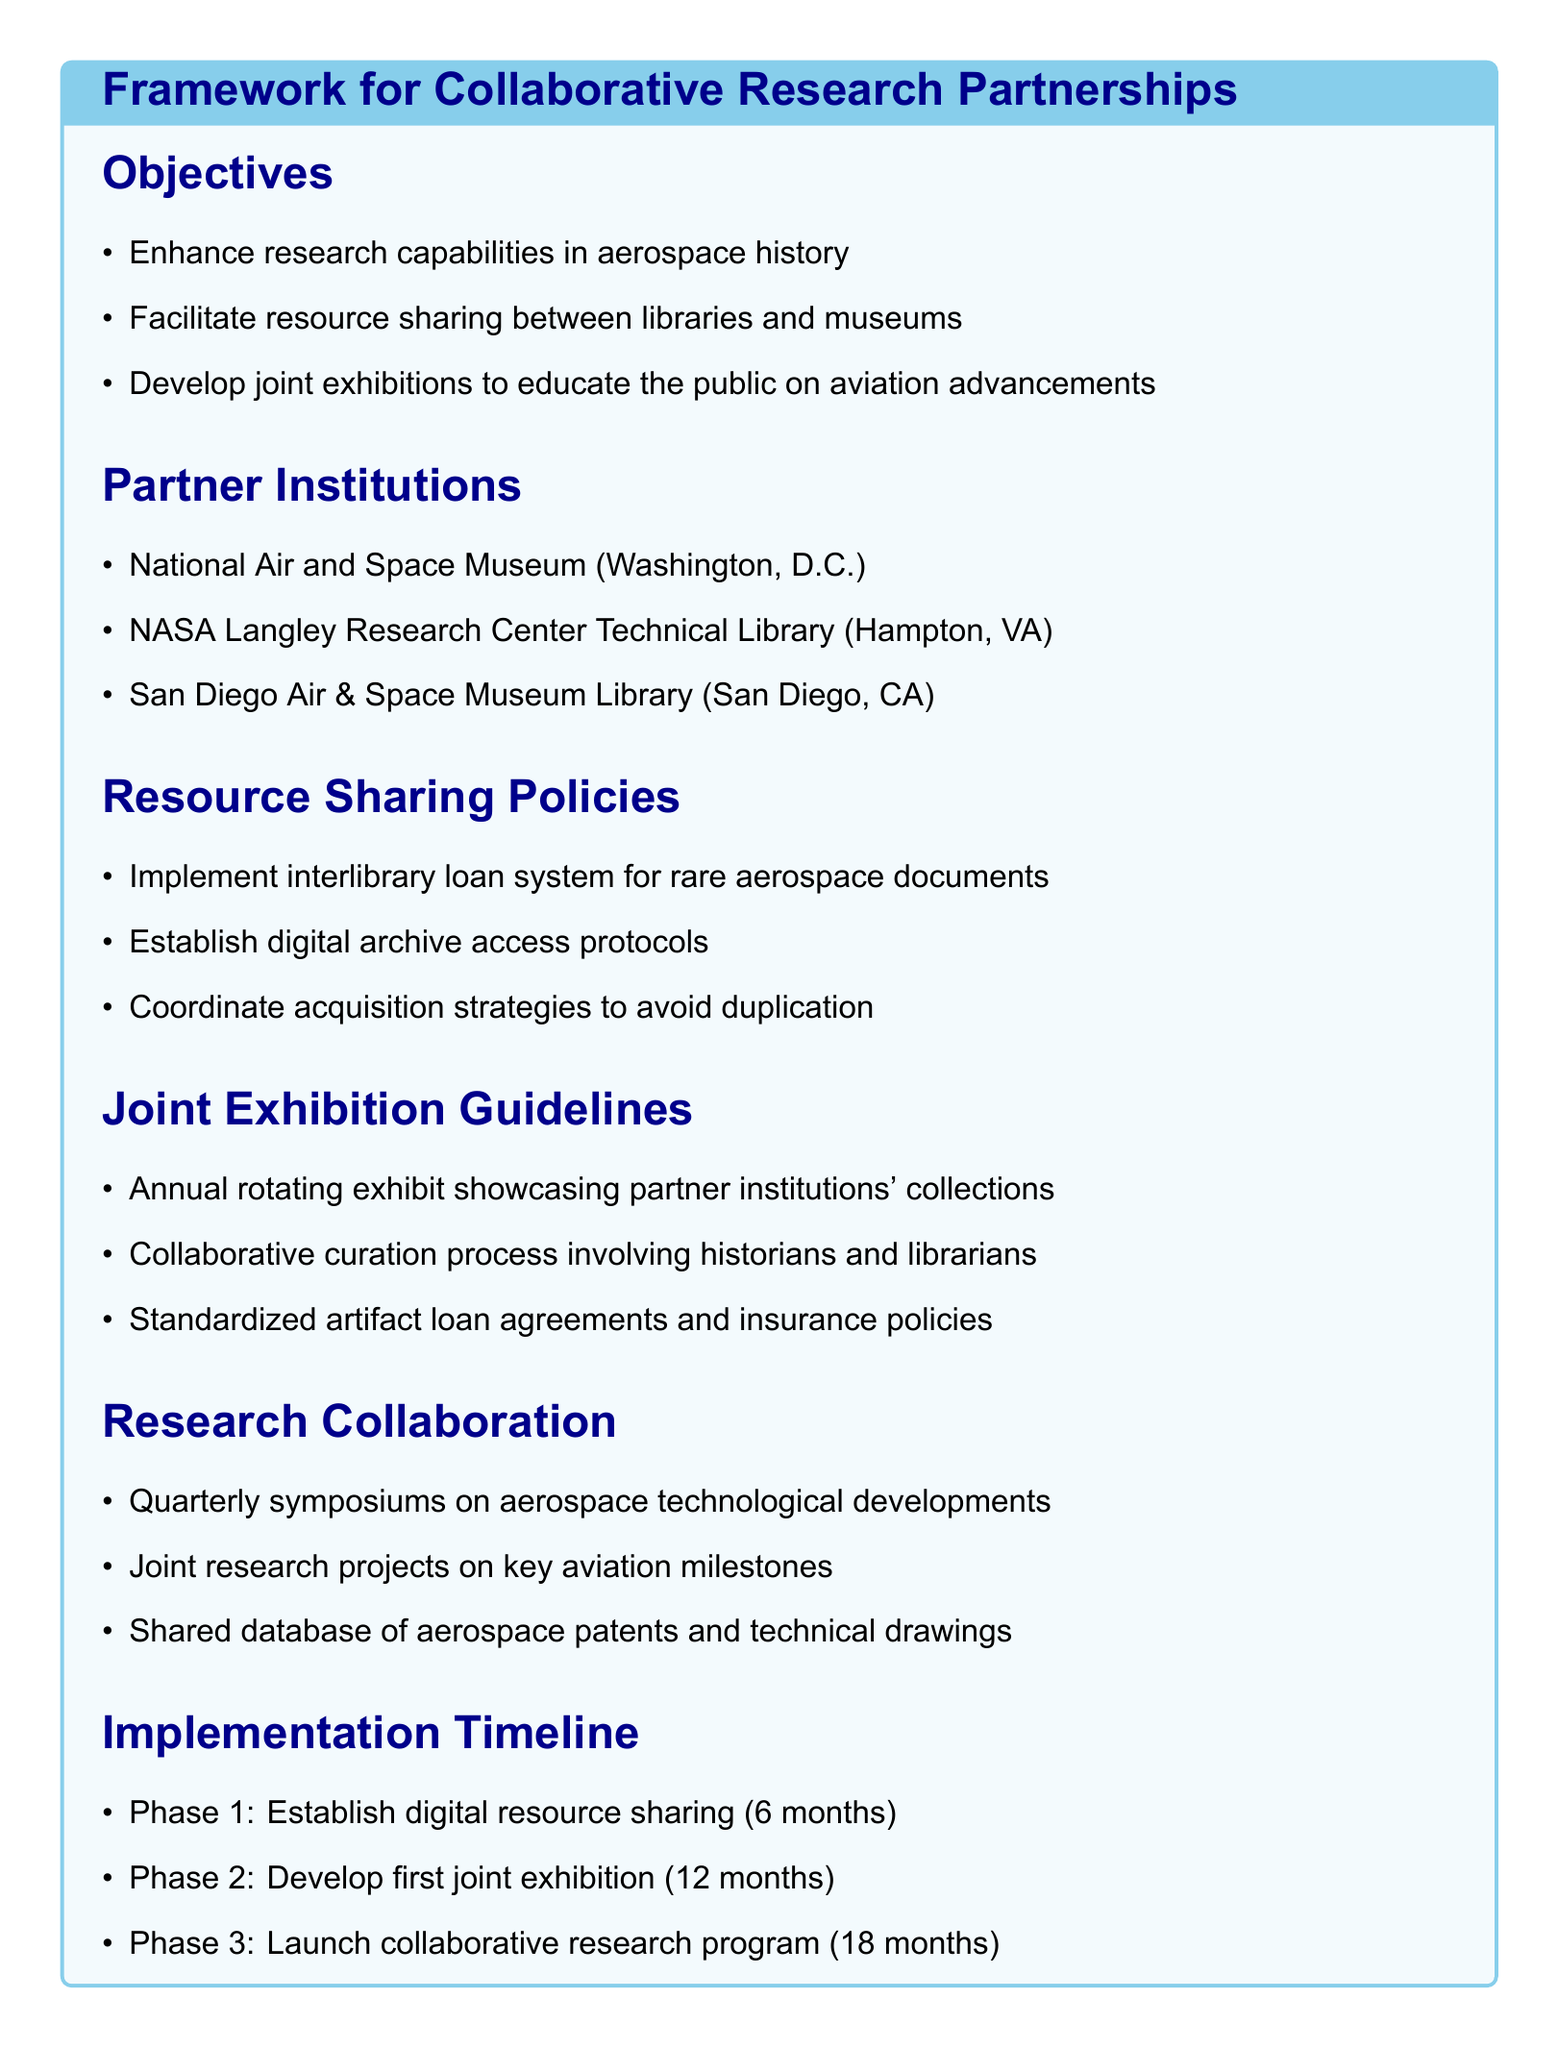What is the main objective of the framework? The main objectives include enhancing research capabilities, facilitating resource sharing, and developing joint exhibitions.
Answer: Enhance research capabilities in aerospace history How many partner institutions are listed? The document lists three partner institutions involved in the collaborative effort.
Answer: 3 What type of museum is included as a partner institution? The document includes the National Air and Space Museum as a partner institution.
Answer: Aviation museum What is the duration of Phase 1 in the implementation timeline? Phase 1 involves establishing digital resource sharing, which is said to last six months.
Answer: 6 months What is the focus of the quarterly symposiums? The quarterly symposiums focus on technological developments in aerospace.
Answer: Aerospace technological developments What is one policy related to resource sharing? The document mentions implementing an interlibrary loan system for rare aerospace documents.
Answer: Interlibrary loan system Which phase involves the development of the first joint exhibition? The document identifies Phase 2 as the stage for developing the first joint exhibition.
Answer: Phase 2 How will the exhibitions be curated according to the guidelines? The exhibitions will involve a collaborative curation process.
Answer: Collaborative curation process What resource will be shared during the research collaboration? A shared database of aerospace patents and technical drawings will be part of the research collaboration.
Answer: Shared database of aerospace patents and technical drawings 